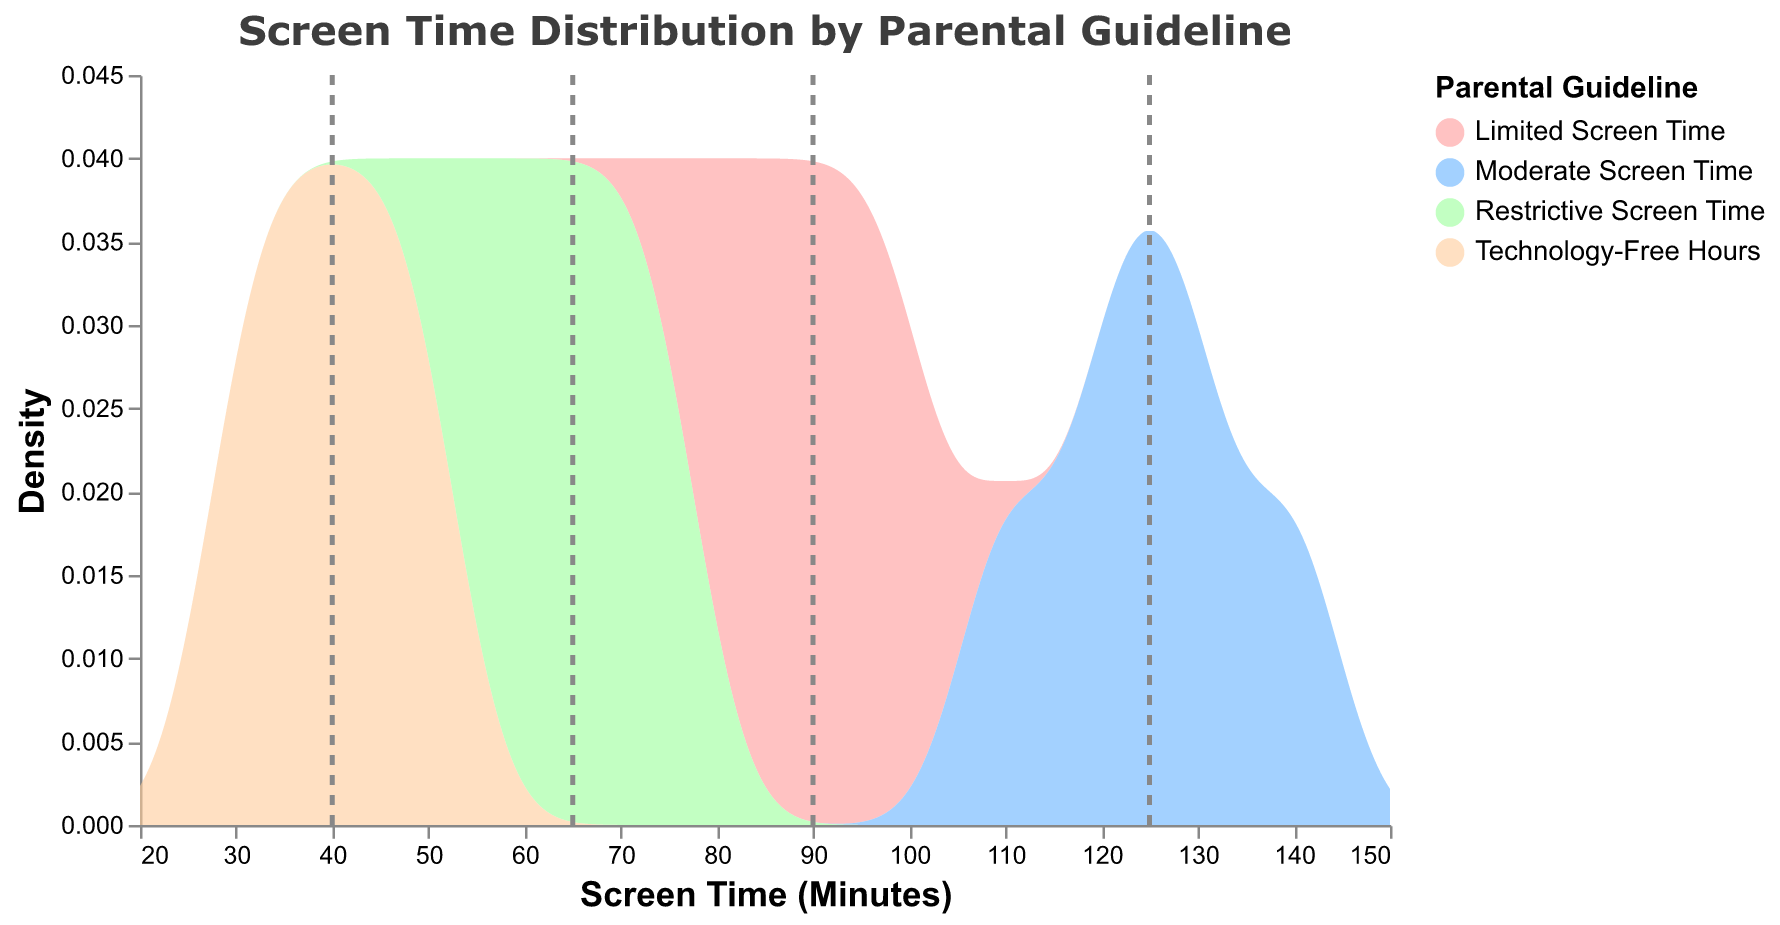What is the title of the figure? The title is displayed at the top of the graph, and it summarizes the subject of the plot.
Answer: Screen Time Distribution by Parental Guideline Which parental guideline has the lowest average screen time? The plot includes dashed rules indicating the means of each group. The Technology-Free Hours group has the lowest average as its dashed line is farthest to the left among all groups.
Answer: Technology-Free Hours What is the average screen time for the Limited Screen Time group? Identify the dashed line for the Limited Screen Time group and read its position on the x-axis. The dashed line is around 90 minutes.
Answer: 90 minutes Between which values does the data for screen time range? Look at the x-axis, and note the minimum and maximum values spanned by the densities of all groups combined. The range covers from 20 to 150 minutes.
Answer: 20 to 150 minutes How many different parental guidelines are represented in the plot? Each color represents a different guideline and is identified in the legend on the right side of the plot. There are four guidelines listed.
Answer: 4 Which parental guideline has the most tightly clustered screen time distribution? The distribution's width on the x-axis indicates spread. The Technology-Free Hours group has the most tightly clustered screen time distribution as it covers the least range of values.
Answer: Technology-Free Hours What group has the widest range in their screen time? The range can be seen by the colored area spanning the x-axis. The Moderate Screen Time group covers the widest range, from about 110 to 140 minutes, indicating the widest spread.
Answer: Moderate Screen Time How does the density peak of the Restrictive Screen Time compare to the density peak of the Limited Screen Time? The height of the density peaks can be visually compared. The Restrictive Screen Time has a slightly higher density peak compared to the Limited Screen Time group.
Answer: Restrictive Screen Time has a higher peak 